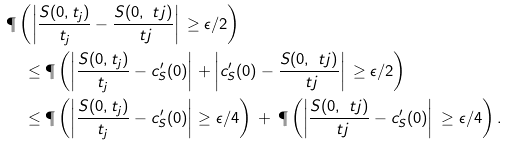Convert formula to latex. <formula><loc_0><loc_0><loc_500><loc_500>& \P \left ( \left | \frac { S ( 0 , t _ { j } ) } { t _ { j } } - \frac { S ( 0 , \ t j ) } { \ t j } \right | \, \geq \epsilon / 2 \right ) \\ & \quad \leq \P \left ( \left | \frac { S ( 0 , t _ { j } ) } { t _ { j } } - c _ { S } ^ { \prime } ( 0 ) \right | + \left | c _ { S } ^ { \prime } ( 0 ) - \frac { S ( 0 , \ t j ) } { \ t j } \right | \, \geq \epsilon / 2 \right ) \\ & \quad \leq \P \left ( \left | \frac { S ( 0 , t _ { j } ) } { t _ { j } } - c _ { S } ^ { \prime } ( 0 ) \right | \geq \epsilon / 4 \right ) \, + \, \P \left ( \left | \frac { S ( 0 , \ t j ) } { \ t j } - c _ { S } ^ { \prime } ( 0 ) \right | \, \geq \epsilon / 4 \right ) .</formula> 